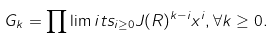Convert formula to latex. <formula><loc_0><loc_0><loc_500><loc_500>G _ { k } = \prod \lim i t s _ { i \geq 0 } J ( R ) ^ { k - i } x ^ { i } , \forall k \geq 0 .</formula> 